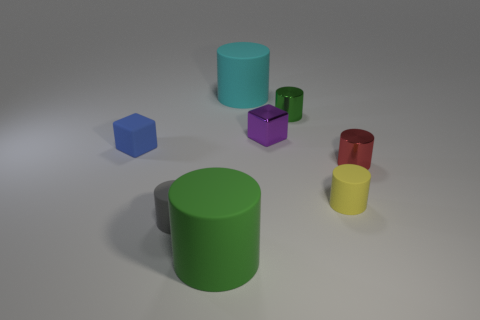Subtract all yellow cylinders. How many cylinders are left? 5 Subtract all tiny red metallic cylinders. How many cylinders are left? 5 Subtract all gray cylinders. Subtract all brown cubes. How many cylinders are left? 5 Add 1 tiny green metal objects. How many objects exist? 9 Subtract all cylinders. How many objects are left? 2 Add 8 shiny cylinders. How many shiny cylinders exist? 10 Subtract 0 cyan blocks. How many objects are left? 8 Subtract all red shiny objects. Subtract all red cylinders. How many objects are left? 6 Add 2 tiny purple shiny things. How many tiny purple shiny things are left? 3 